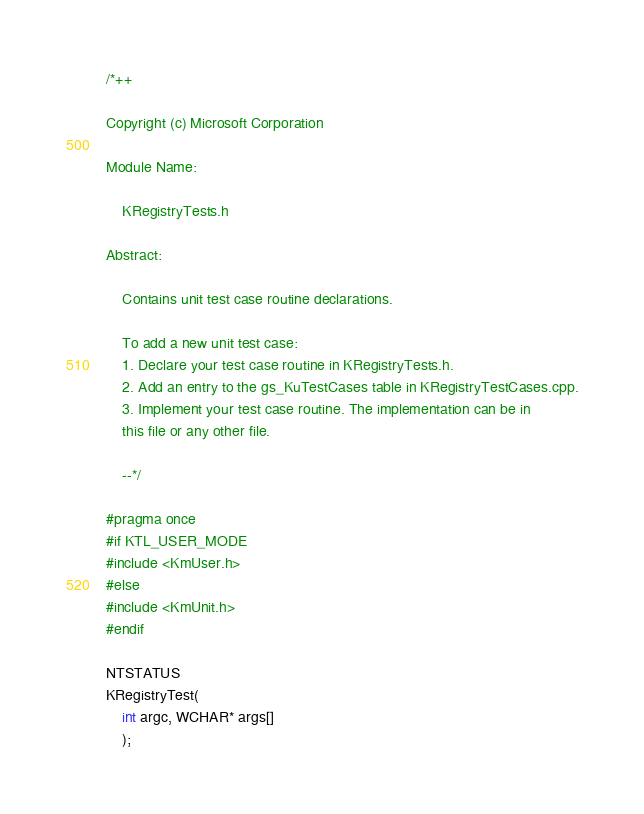Convert code to text. <code><loc_0><loc_0><loc_500><loc_500><_C_>/*++

Copyright (c) Microsoft Corporation

Module Name:

    KRegistryTests.h

Abstract:

    Contains unit test case routine declarations.

    To add a new unit test case:
    1. Declare your test case routine in KRegistryTests.h.
    2. Add an entry to the gs_KuTestCases table in KRegistryTestCases.cpp.
    3. Implement your test case routine. The implementation can be in
    this file or any other file.

    --*/

#pragma once
#if KTL_USER_MODE
#include <KmUser.h>
#else
#include <KmUnit.h>
#endif

NTSTATUS
KRegistryTest(
    int argc, WCHAR* args[]
    );
</code> 